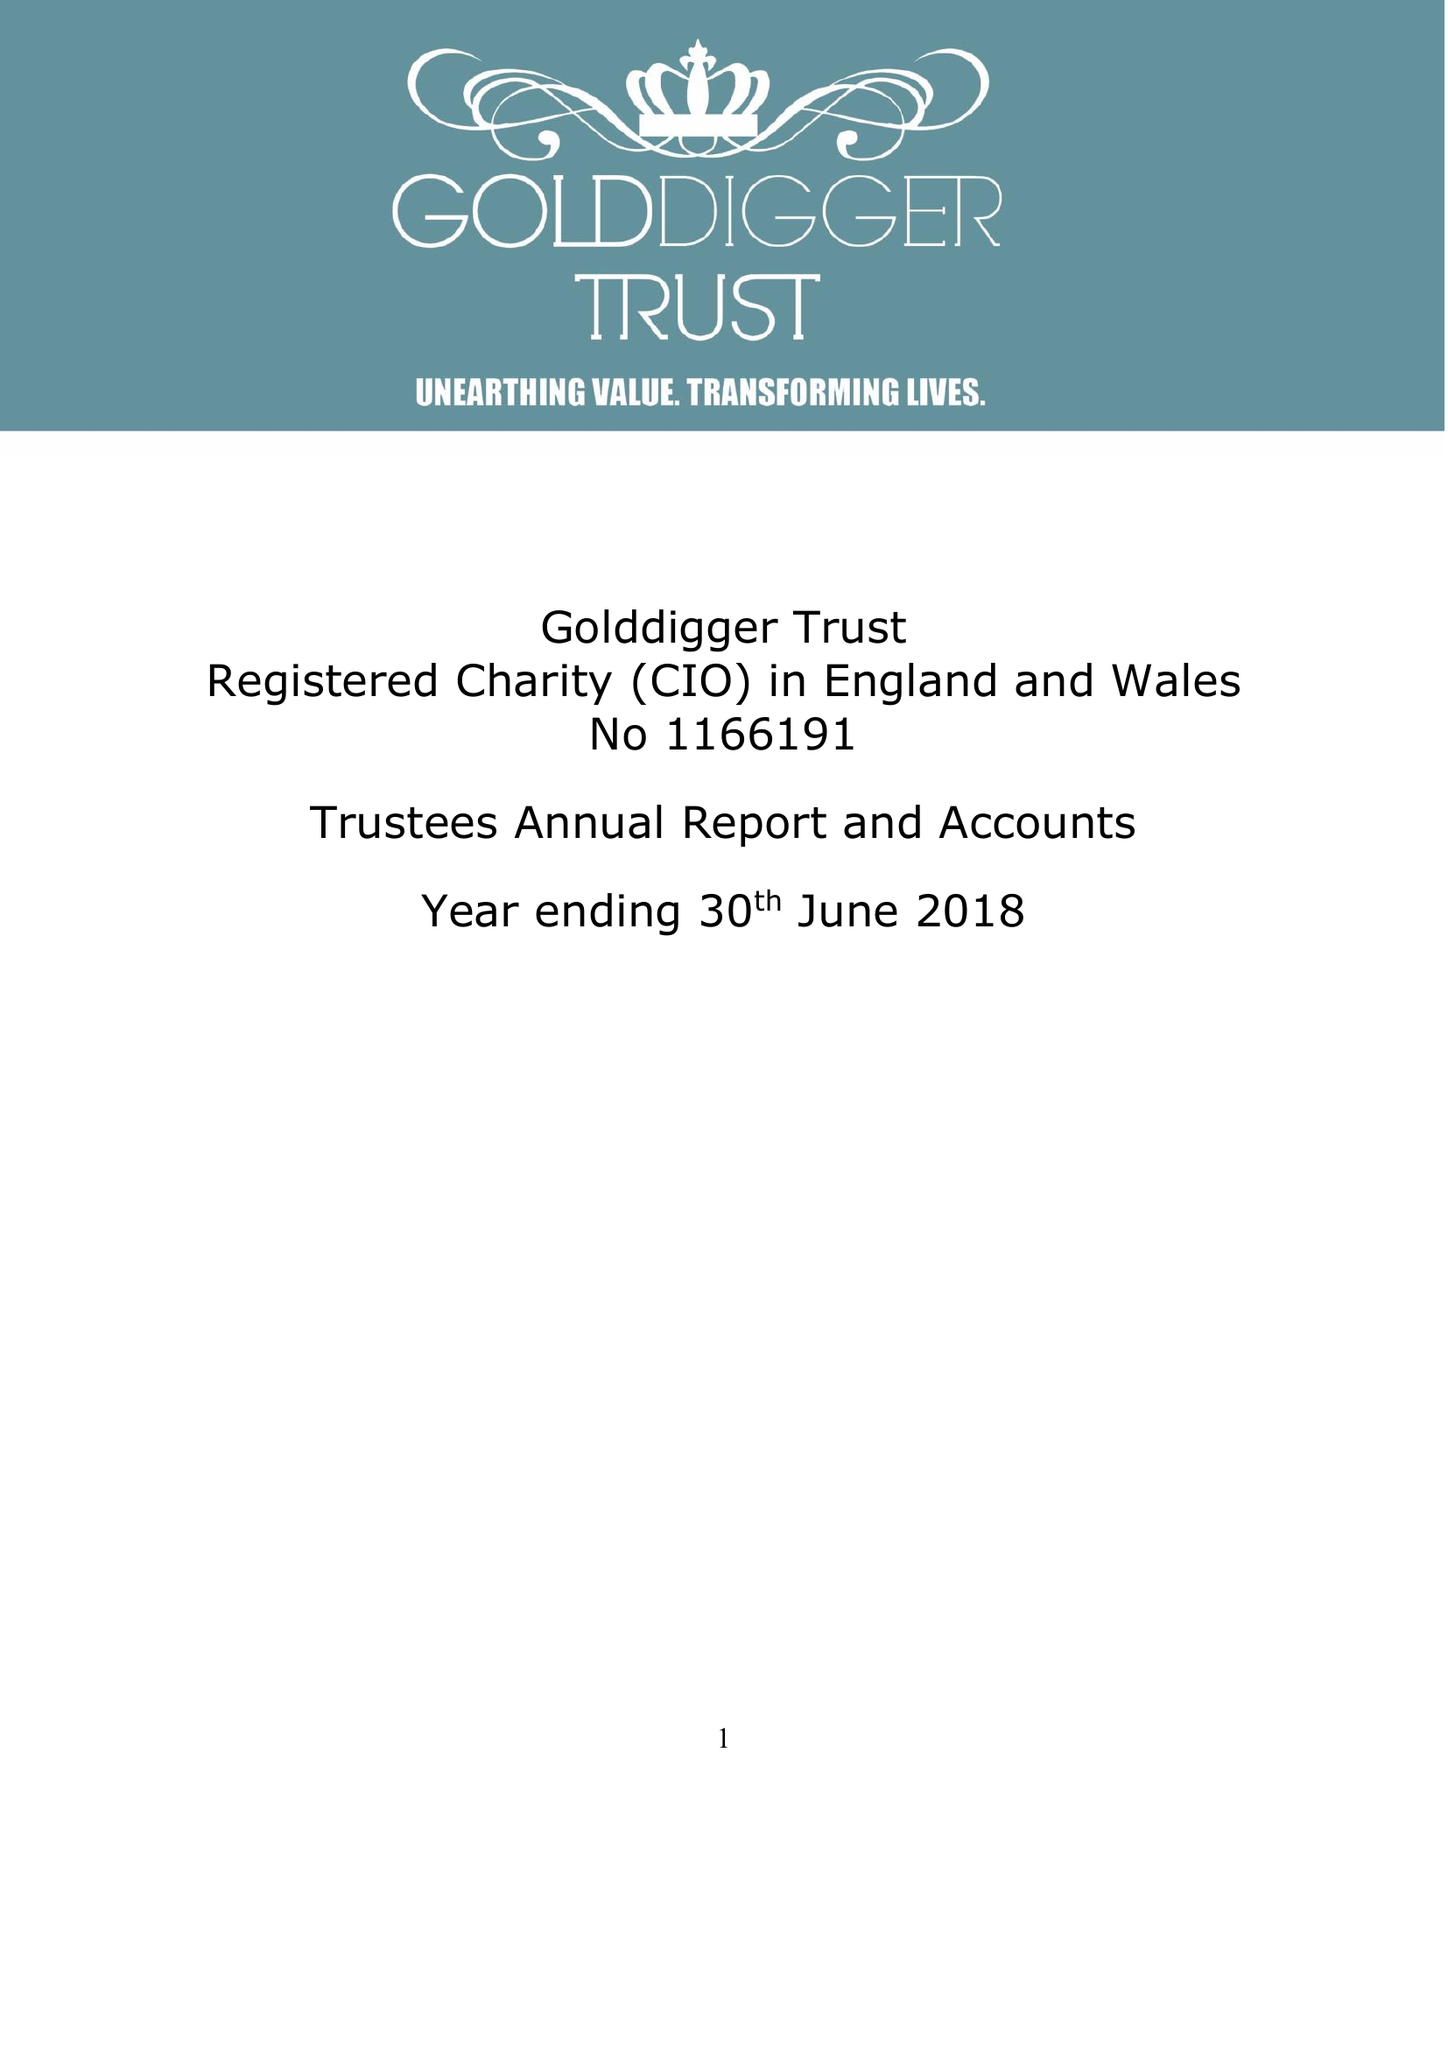What is the value for the charity_number?
Answer the question using a single word or phrase. 1166191 